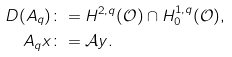Convert formula to latex. <formula><loc_0><loc_0><loc_500><loc_500>D ( A _ { q } ) & \colon = H ^ { 2 , q } ( \mathcal { O } ) \cap H _ { 0 } ^ { 1 , q } ( \mathcal { O } ) , \\ A _ { q } x & \colon = \mathcal { A } y .</formula> 